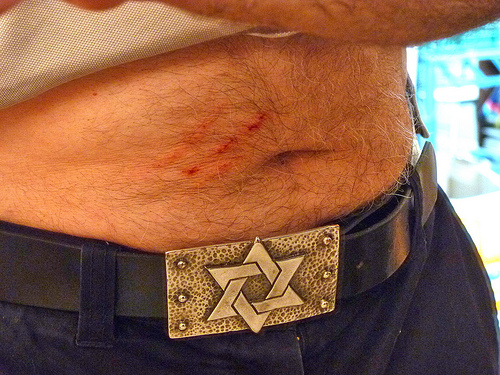<image>
Is the scratch above the star? Yes. The scratch is positioned above the star in the vertical space, higher up in the scene. 